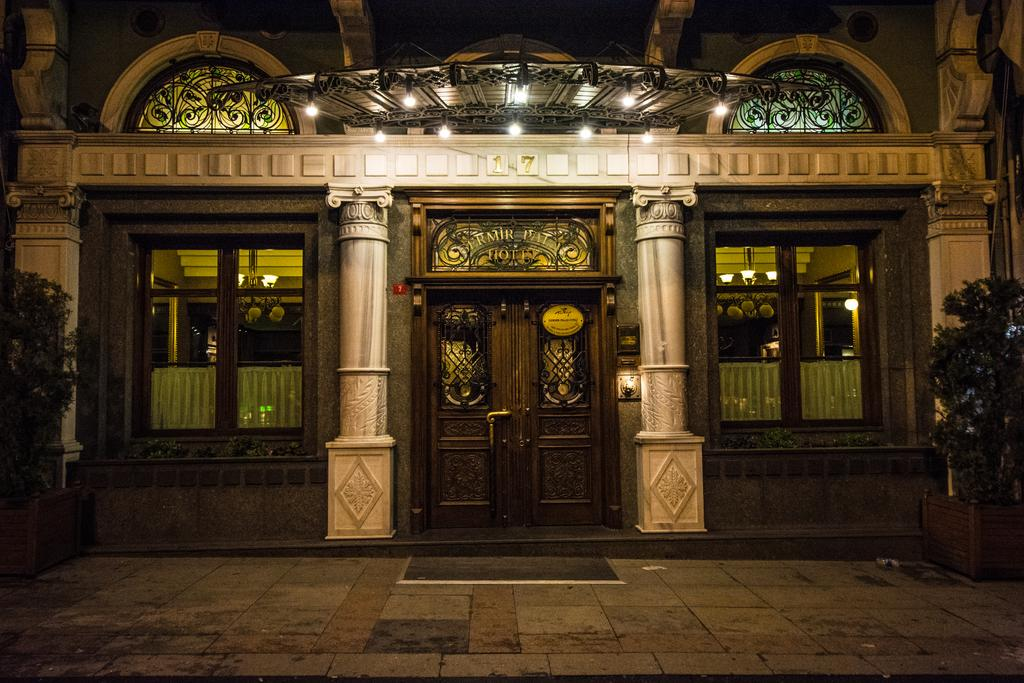What type of structure can be seen in the image? There is a building in the image. What architectural features are present in the building? There are pillars in the image. How can one enter the building? There is a door in the image. Are there any openings for light and ventilation? Yes, there are windows in the image. What type of lighting is present in the building? There are ceiling lights and other lights in the image. Are there any plants inside the building? Yes, there are plants in the image. What is the floor made of? The floor is visible in the image. Is there any floor covering or decoration? There is a mat in the image. What is the board used for in the image? There is a board in the image, but its purpose is not specified. Can you describe any other objects present in the image? There are other objects in the image, but their specific details are not mentioned. How many men with authority are present in the image? There is no mention of men or authority figures in the image. What is the thumb doing in the image? There is no thumb present in the image. 